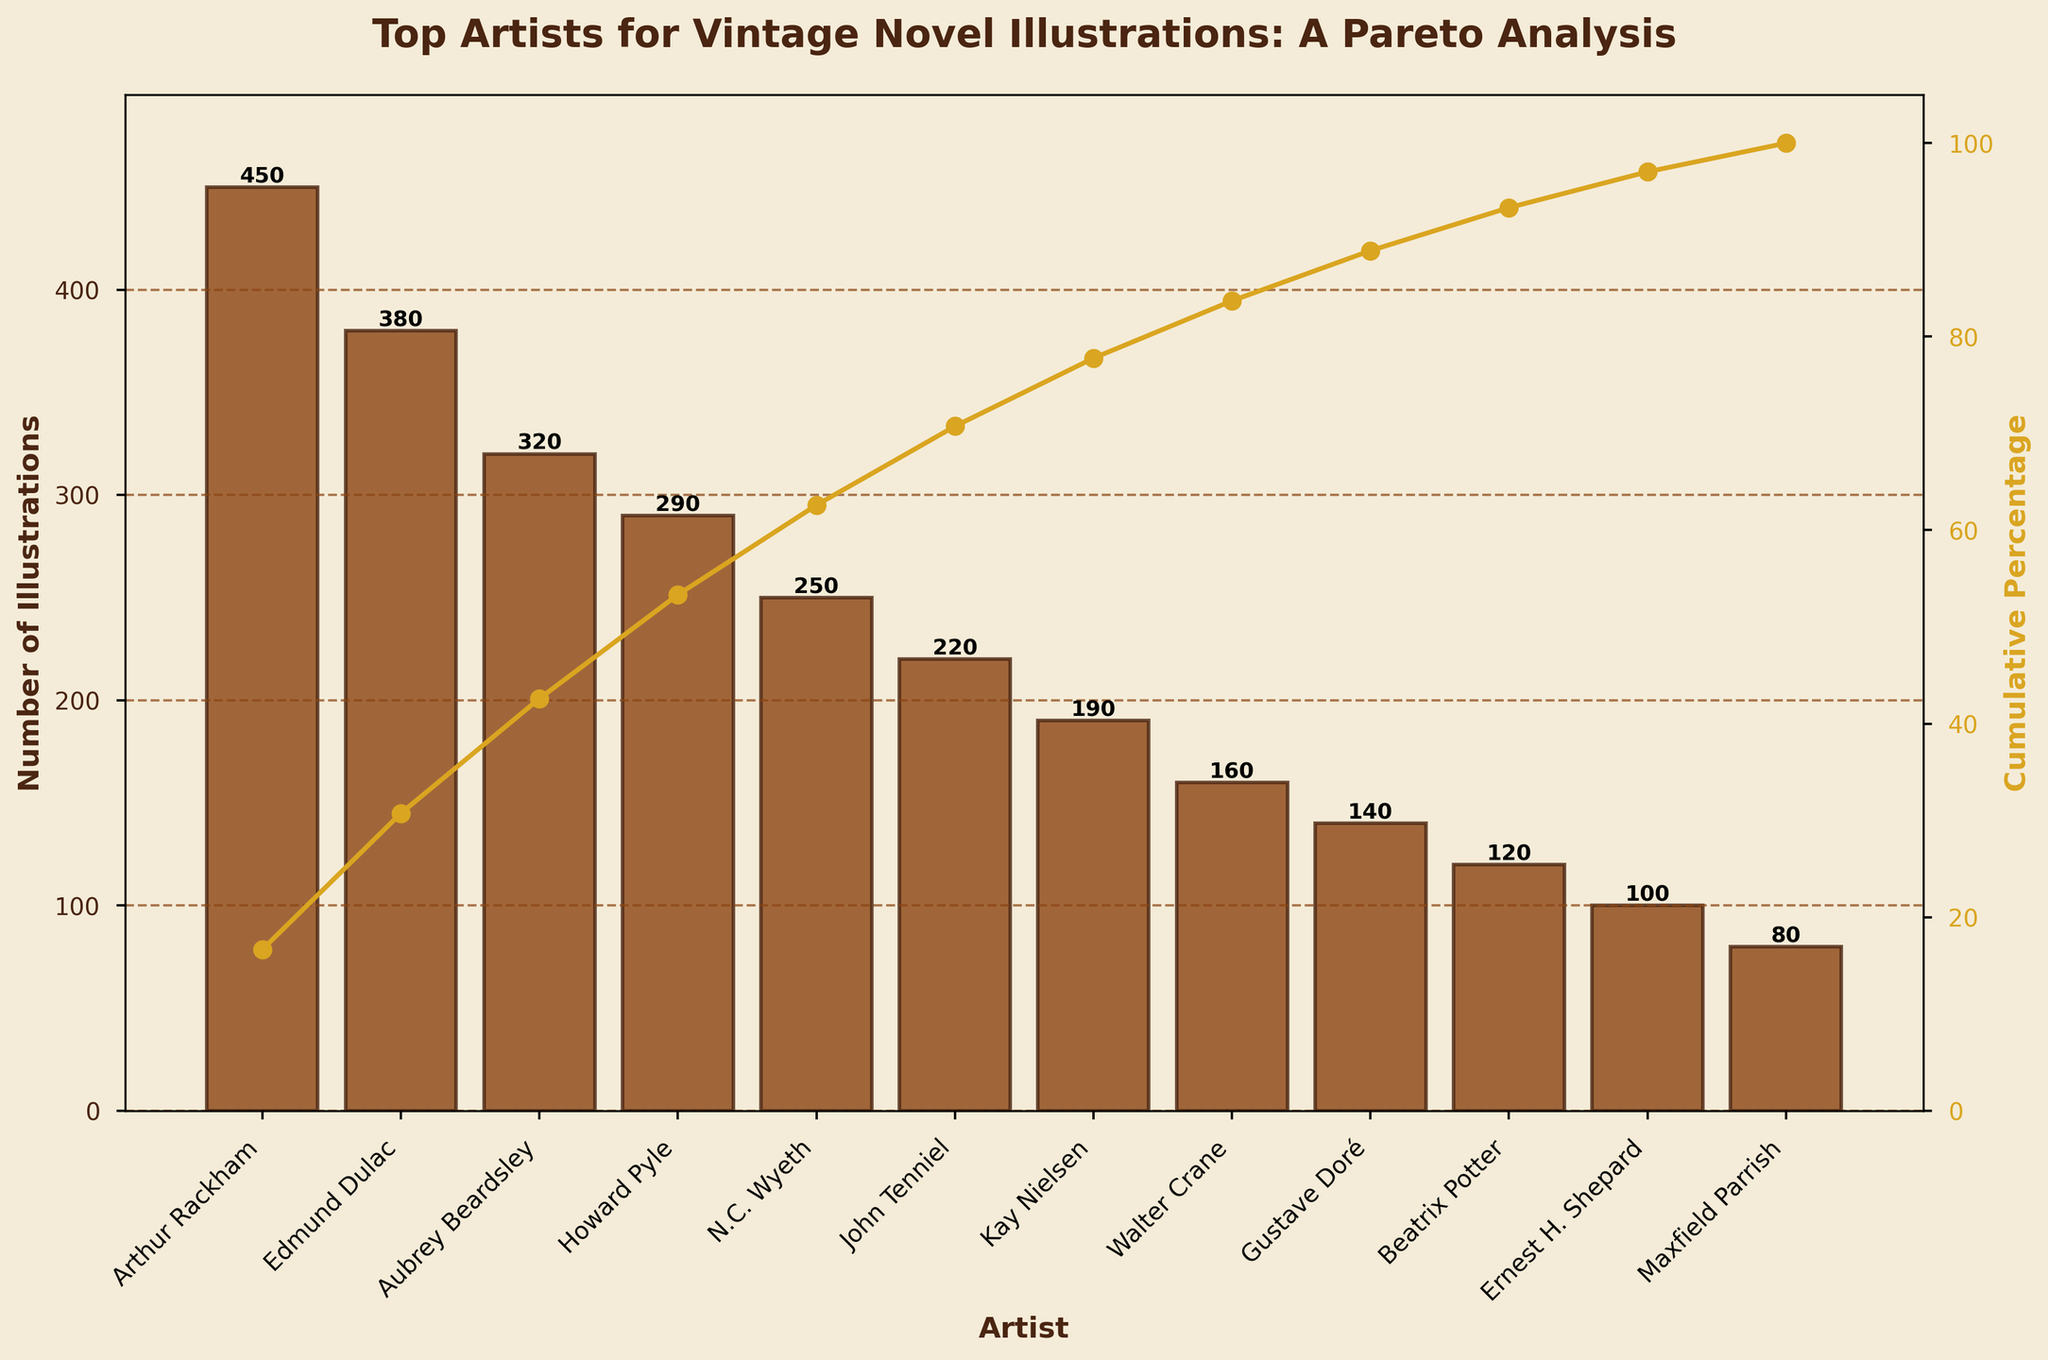What is the title of the figure? The title of the figure is located at the top. It reads "Top Artists for Vintage Novel Illustrations: A Pareto Analysis."
Answer: Top Artists for Vintage Novel Illustrations: A Pareto Analysis Which artist produced the most illustrations? The artist with the highest bar in the figure is Arthur Rackham, with 450 illustrations.
Answer: Arthur Rackham What cumulative percentage does John Tenniel's bar contribute to? John Tenniel's bar is the sixth one from the left. Tracing it to the line on the secondary y-axis, it contributes around 80% cumulatively.
Answer: 80% How many more illustrations did Arthur Rackham produce compared to Maxfield Parrish? Arthur Rackham's bar shows 450 illustrations, and Maxfield Parrish's bar shows 80 illustrations. Subtracting these numbers gives 450 - 80 = 370.
Answer: 370 How many artists have produced more than 200 illustrations? Looking at the bars and counting those with more than 200 illustrations, we find Arthur Rackham, Edmund Dulac, Aubrey Beardsley, and Howard Pyle. This makes a total of 4 artists.
Answer: 4 What is the difference in the cumulative percentage between the artists with the most and the least illustrations? The cumulative percentage at Arthur Rackham (most illustrations) is about 20%, and for Maxfield Parrish (least illustrations) it is about 98%. The difference is 98% - 20% = 78%.
Answer: 78% Which two artists have the closest number of illustrations, and what is the difference? By observing the height of the bars, Howard Pyle (290) and N.C. Wyeth (250) are the closest. Their difference in illustrations is 290 - 250 = 40.
Answer: Howard Pyle and N.C. Wyeth, 40 What percentage of the total illustrations does Gustave Doré contribute alone? Gustave Doré's bar indicates 140 illustrations. The total number of illustrations is 2,900. Thus, his percentage is (140 / 2,900) * 100 ≈ 4.83%.
Answer: 4.83% Between Kay Nielsen and Walter Crane, who has a higher number of illustrations, and by how many? Kay Nielsen has 190 illustrations, while Walter Crane has 160. The difference is 190 - 160 = 30.
Answer: Kay Nielsen, 30 